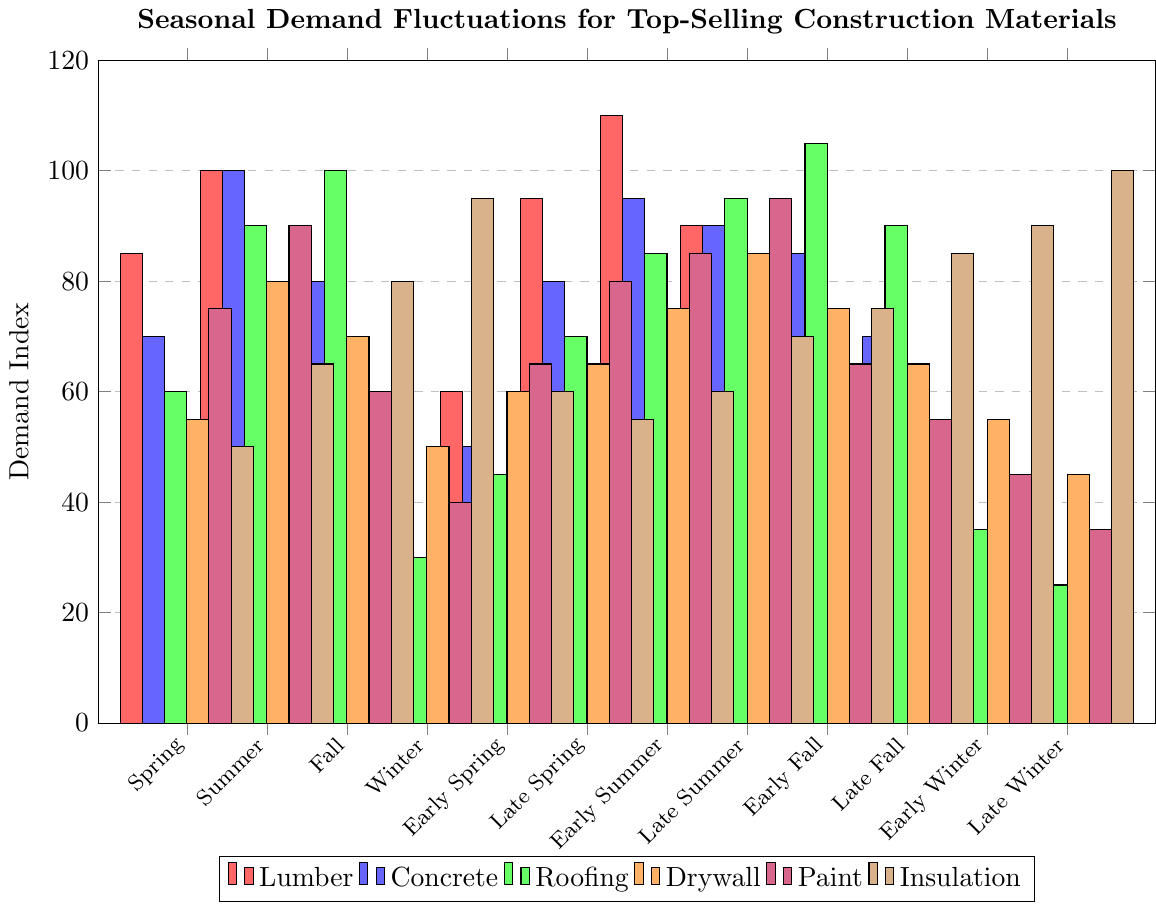Which material has the highest demand in Early Summer? The chart shows that the height of the red bar (Lumber) is the highest among all materials during Early Summer, indicating the highest demand.
Answer: Lumber How does the demand for Insulation change from Summer to Winter? The demand for Insulation in Summer is at a medium height and then peaks sharply in Winter, indicating a significant increase.
Answer: Increase Which season shows the lowest demand for Concrete? Observing the heights of the blue bars, Winter has the shortest bar, indicating the lowest demand for Concrete.
Answer: Winter Compare the demand for Paint during Early Spring and Late Spring. The purple bar for Paint in Early Spring is at height 65, while in Late Spring it's at height 80, so demand increases.
Answer: Late Spring > Early Spring What's the average demand for Roofing across all seasons? Sum the heights of the green bars for all seasons and divide by the number of seasons: (60+90+100+30+45+70+85+95+105+90+35+25) / 12 = 66.25.
Answer: 66.25 In which season is the demand for Drywall the highest? The chart shows the highest orange bar in Summer, indicating the highest demand for Drywall in that season.
Answer: Summer Compare the spring seasons (Spring, Early Spring, Late Spring) for the demand of Lumber. Which has the highest average demand? Sum the heights of the red bars for Spring (85), Early Spring (60), and Late Spring (95), then divide by 3. Results: (85+60+95)/3 = 80. Late Spring has the highest individual demand of 95.
Answer: Late Spring What is the difference in demand for Paint and Insulation during Late Fall? The chart shows a purple bar (Paint) at 55 and a brown bar (Insulation) at 85 during Late Fall. The difference is 85 - 55 = 30.
Answer: 30 Which material exhibits the most noticeable seasonal fluctuation in demand? Comparing the bars for each material across seasons, Insulation (brown bars) shows the most significant fluctuations, ranging from a low in Summer to a peak in Winter.
Answer: Insulation 